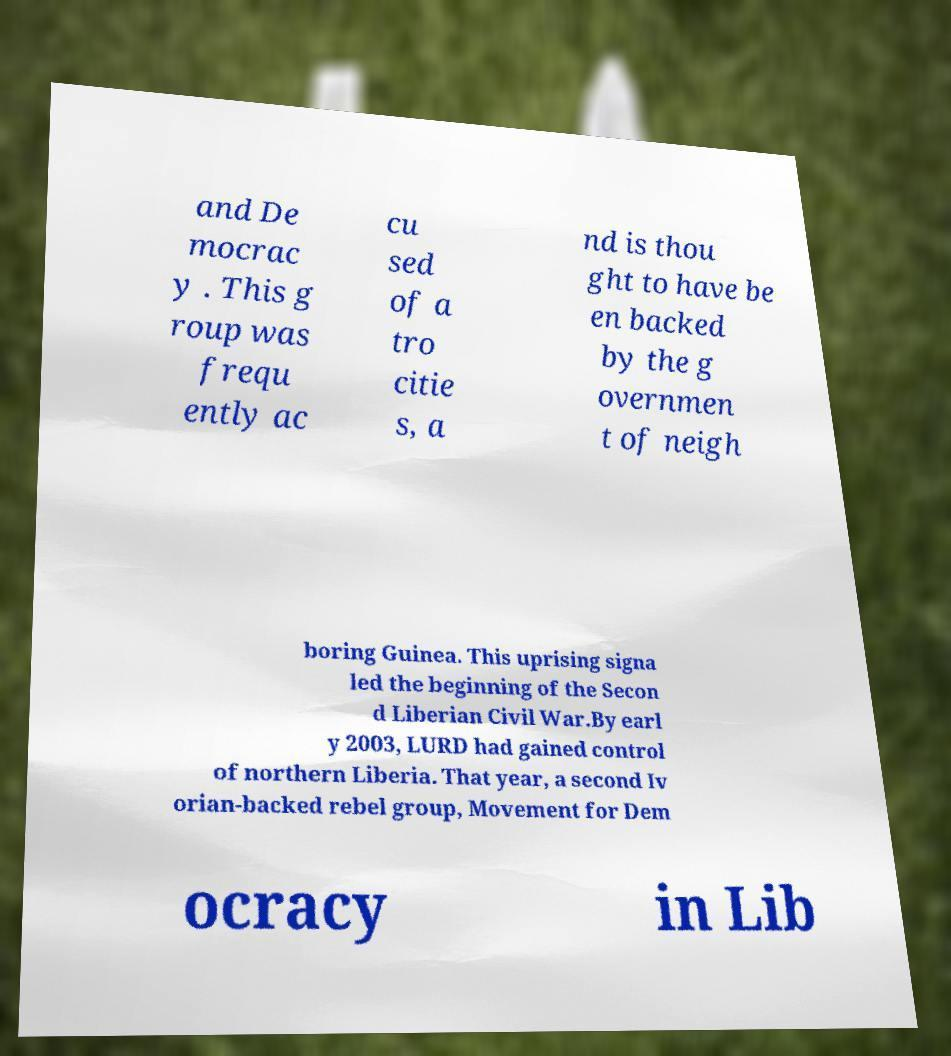Please read and relay the text visible in this image. What does it say? and De mocrac y . This g roup was frequ ently ac cu sed of a tro citie s, a nd is thou ght to have be en backed by the g overnmen t of neigh boring Guinea. This uprising signa led the beginning of the Secon d Liberian Civil War.By earl y 2003, LURD had gained control of northern Liberia. That year, a second Iv orian-backed rebel group, Movement for Dem ocracy in Lib 